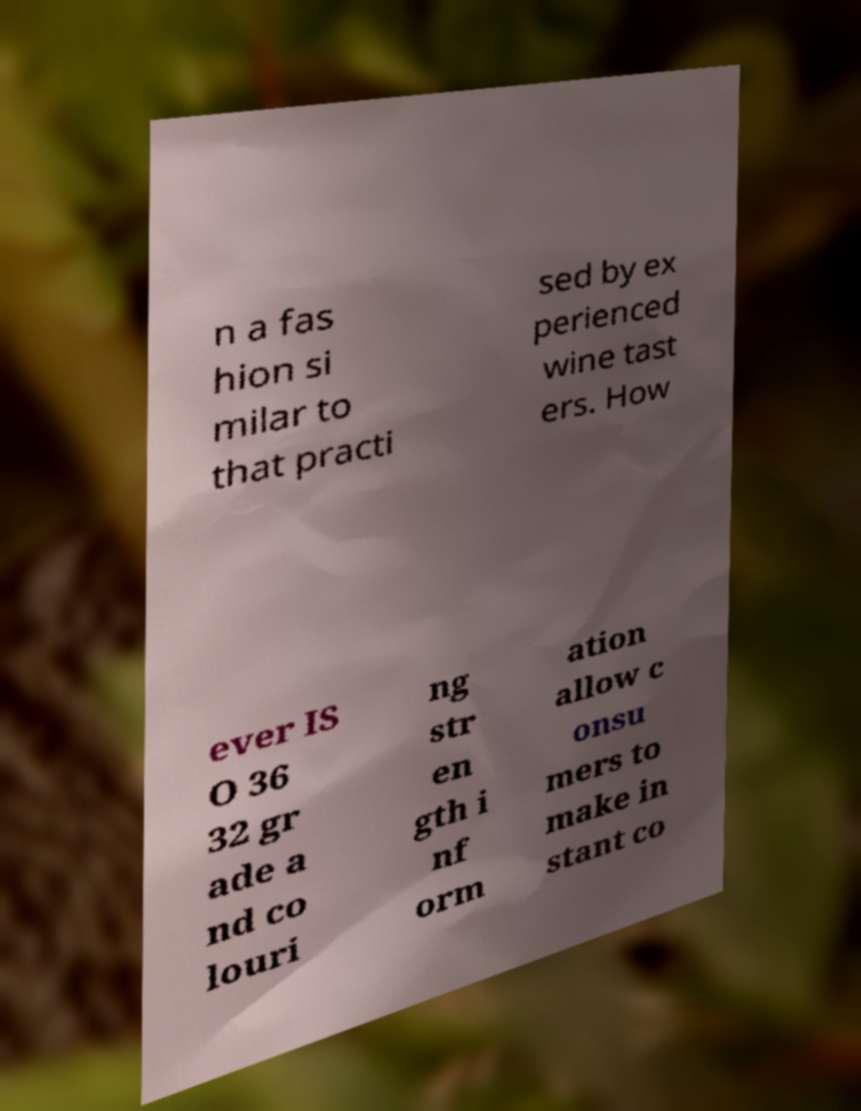Please identify and transcribe the text found in this image. n a fas hion si milar to that practi sed by ex perienced wine tast ers. How ever IS O 36 32 gr ade a nd co louri ng str en gth i nf orm ation allow c onsu mers to make in stant co 